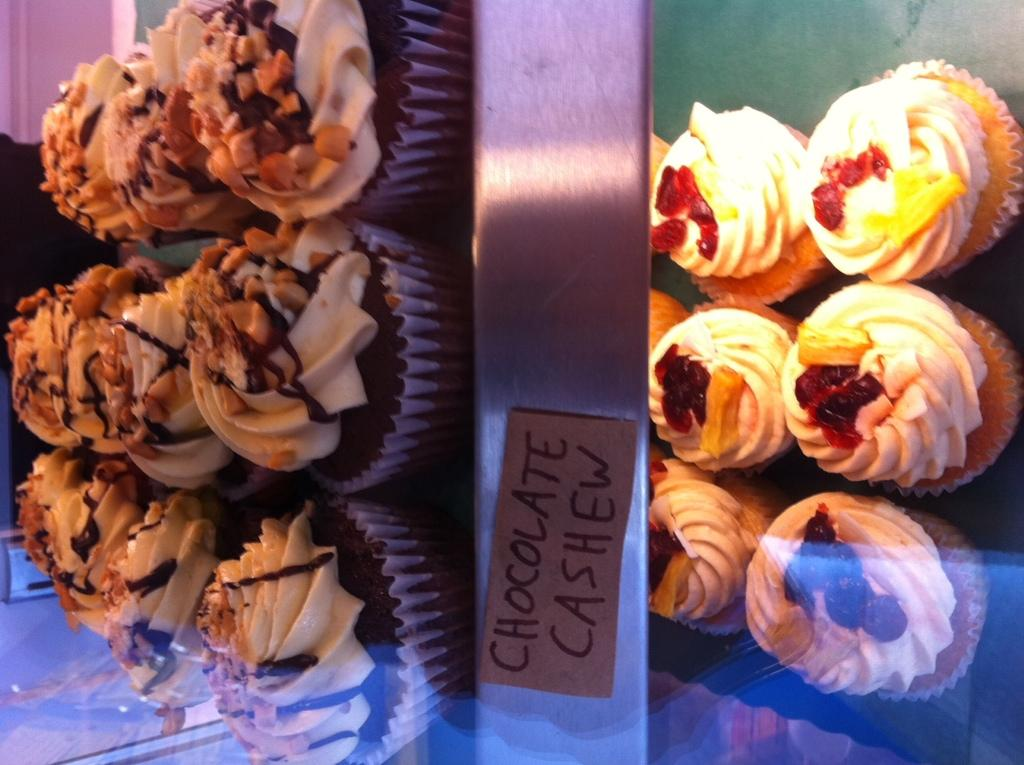What type of chocolate-covered nuts are in the image? There are chocolate cashews in the image. Where are the chocolate cashews located? The chocolate cashews are on a table. How many dinosaurs can be seen eating the chocolate cashews in the image? There are no dinosaurs present in the image. What type of bread product is visible in the image? There is no loaf or bread product visible in the image. Is there a scarecrow standing near the table in the image? There is no scarecrow present in the image. 